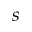<formula> <loc_0><loc_0><loc_500><loc_500>{ s }</formula> 